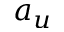Convert formula to latex. <formula><loc_0><loc_0><loc_500><loc_500>a _ { u }</formula> 